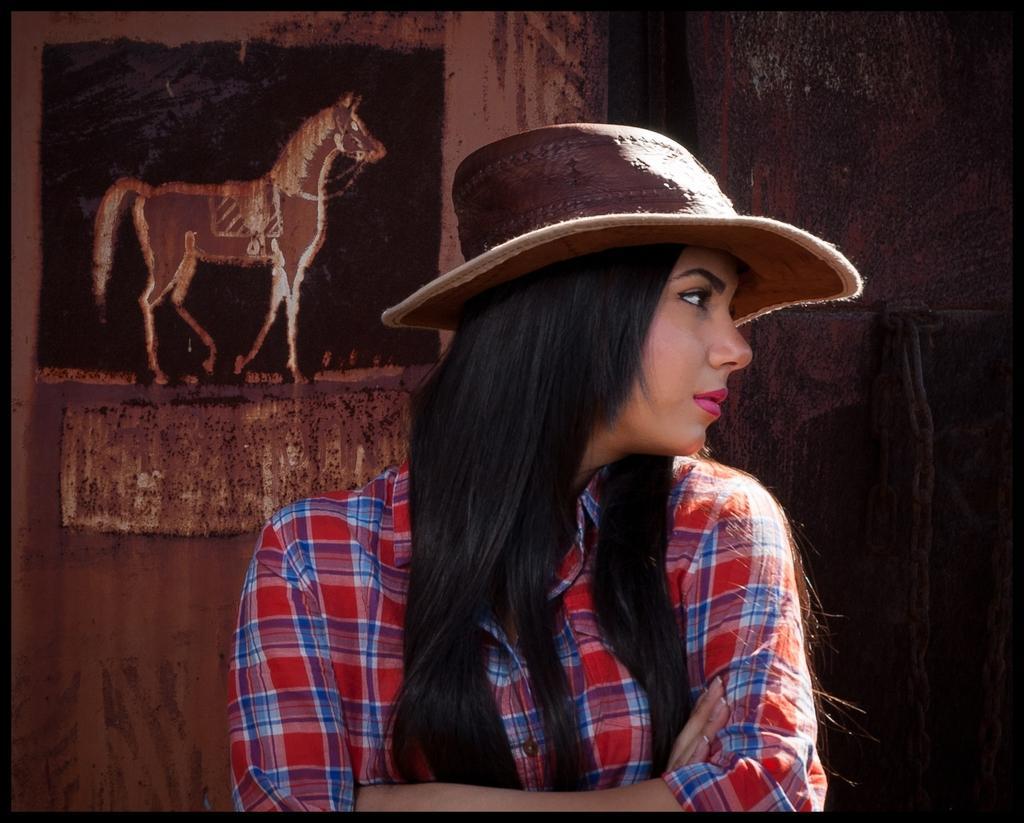Please provide a concise description of this image. In the center of the image we can see a girl standing. She is wearing a hat. In the background there is a wall and we can see a painting on the wall. 